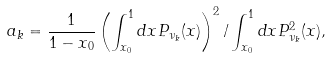<formula> <loc_0><loc_0><loc_500><loc_500>a _ { k } = \frac { 1 } { 1 - x _ { 0 } } \left ( \int ^ { 1 } _ { x _ { 0 } } d x P _ { \nu _ { k } } ( x ) \right ) ^ { 2 } / \int ^ { 1 } _ { x _ { 0 } } d x P _ { \nu _ { k } } ^ { 2 } ( x ) ,</formula> 